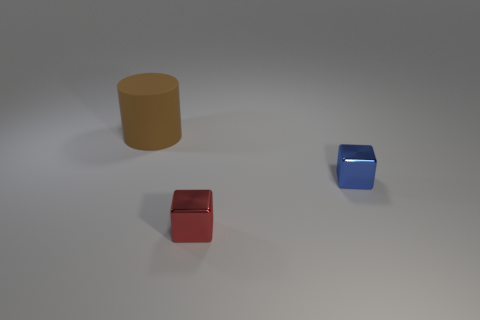What is the shape of the object that is both on the right side of the rubber cylinder and left of the small blue shiny cube?
Your response must be concise. Cube. Are there an equal number of small blue metal things in front of the red shiny object and tiny metal cylinders?
Keep it short and to the point. Yes. How many objects are either cylinders or things that are in front of the large thing?
Offer a very short reply. 3. Are there any other shiny objects that have the same shape as the small blue object?
Give a very brief answer. Yes. Is the number of large rubber things behind the big brown cylinder the same as the number of big brown matte cylinders that are to the left of the red shiny object?
Keep it short and to the point. No. Is there anything else that has the same size as the rubber cylinder?
Keep it short and to the point. No. How many blue objects are either metallic objects or big objects?
Offer a very short reply. 1. How many other things have the same size as the red metallic object?
Make the answer very short. 1. There is a object that is both behind the red metal block and in front of the big brown thing; what color is it?
Offer a terse response. Blue. Are there more cubes on the right side of the red thing than big brown objects?
Offer a very short reply. No. 